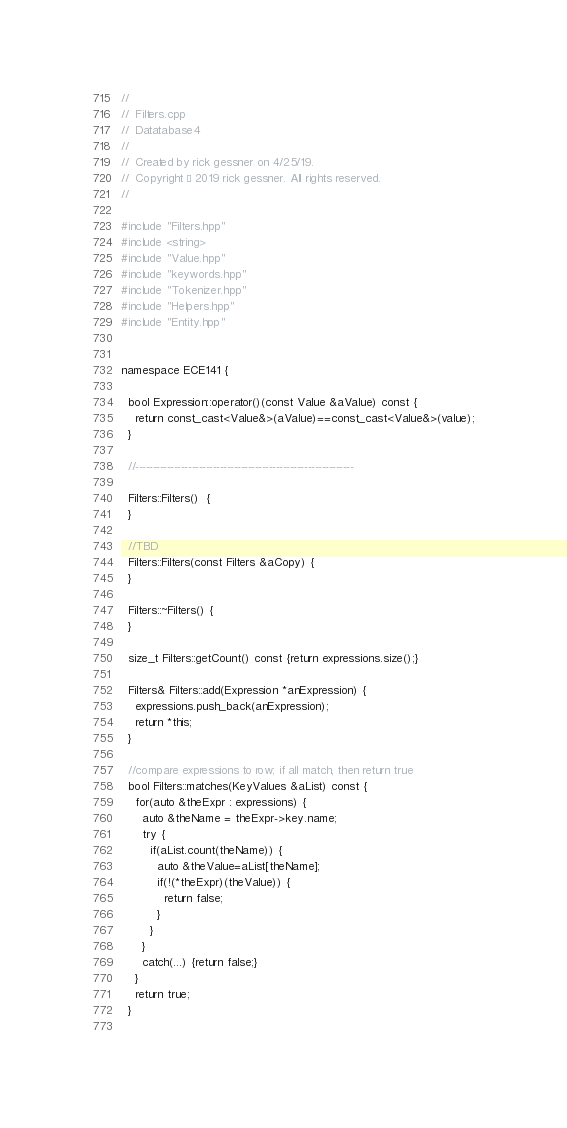Convert code to text. <code><loc_0><loc_0><loc_500><loc_500><_C++_>//
//  Filters.cpp
//  Datatabase4
//
//  Created by rick gessner on 4/25/19.
//  Copyright © 2019 rick gessner. All rights reserved.
//

#include "Filters.hpp"
#include <string>
#include "Value.hpp"
#include "keywords.hpp"
#include "Tokenizer.hpp"
#include "Helpers.hpp"
#include "Entity.hpp"


namespace ECE141 {
  
  bool Expression::operator()(const Value &aValue) const {
    return const_cast<Value&>(aValue)==const_cast<Value&>(value);
  }
  
  //--------------------------------------------------------------
  
  Filters::Filters()  {
  }
  
  //TBD
  Filters::Filters(const Filters &aCopy) {
  }
  
  Filters::~Filters() {
  }
  
  size_t Filters::getCount() const {return expressions.size();}
  
  Filters& Filters::add(Expression *anExpression) {
    expressions.push_back(anExpression);
    return *this;
  }
    
  //compare expressions to row; if all match, then return true
  bool Filters::matches(KeyValues &aList) const {
    for(auto &theExpr : expressions) {
      auto &theName = theExpr->key.name;
      try {
        if(aList.count(theName)) {
          auto &theValue=aList[theName];
          if(!(*theExpr)(theValue)) {
            return false;
          }
        }
      }
      catch(...) {return false;}
    }
    return true;
  }
 </code> 